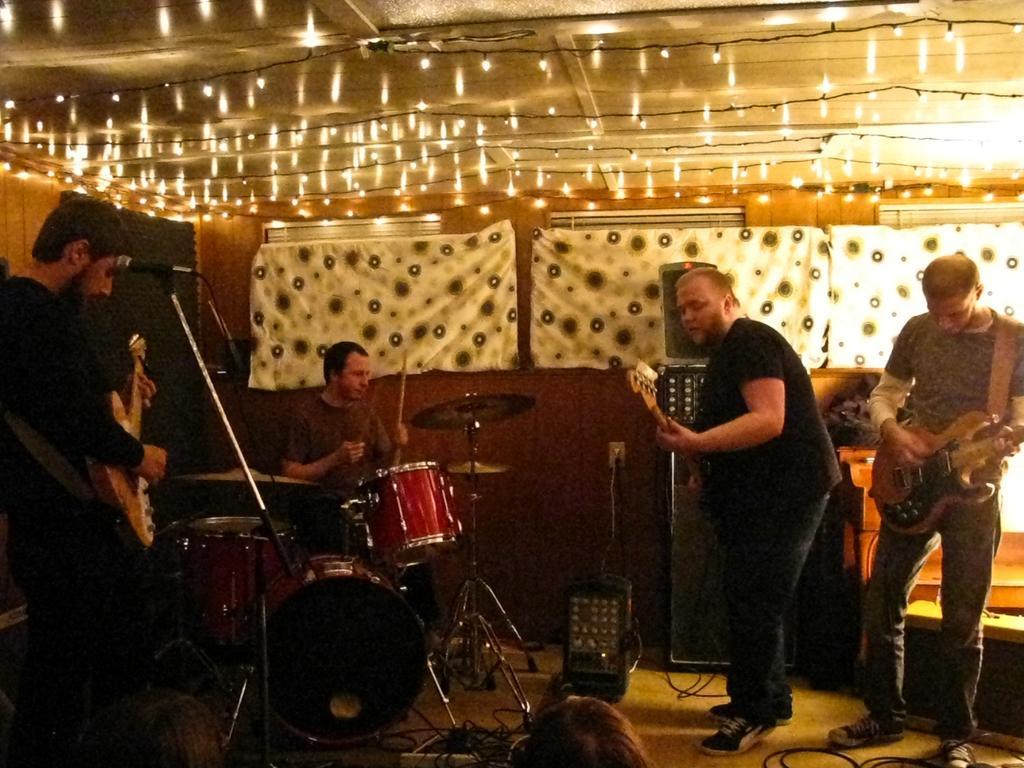How would you summarize this image in a sentence or two? In this image there are two persons who are standing on the right side one person is standing and he is holding a guitar. Beside that person another person who is standing and he is holding a guitar, it seems that he is singing on the left side there is one person who is standing and he is also holding a guitar in front of him there is one mike. Beside that person another person is sitting and he is drumming. On the background of the image there is one wooden wall and some clothes. On the bottom of the image there are some lights and drums on the left side and some lights on the top of the image. 